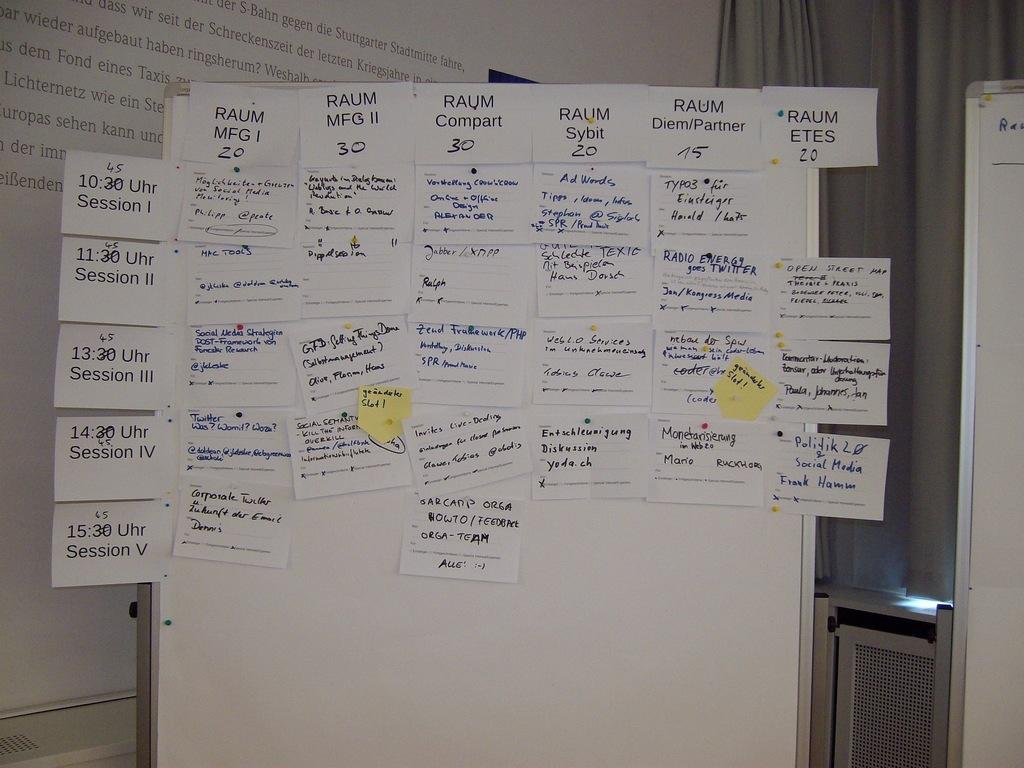<image>
Relay a brief, clear account of the picture shown. Brainstorming session with with post-it notes on a board about maufacturing and session times. 